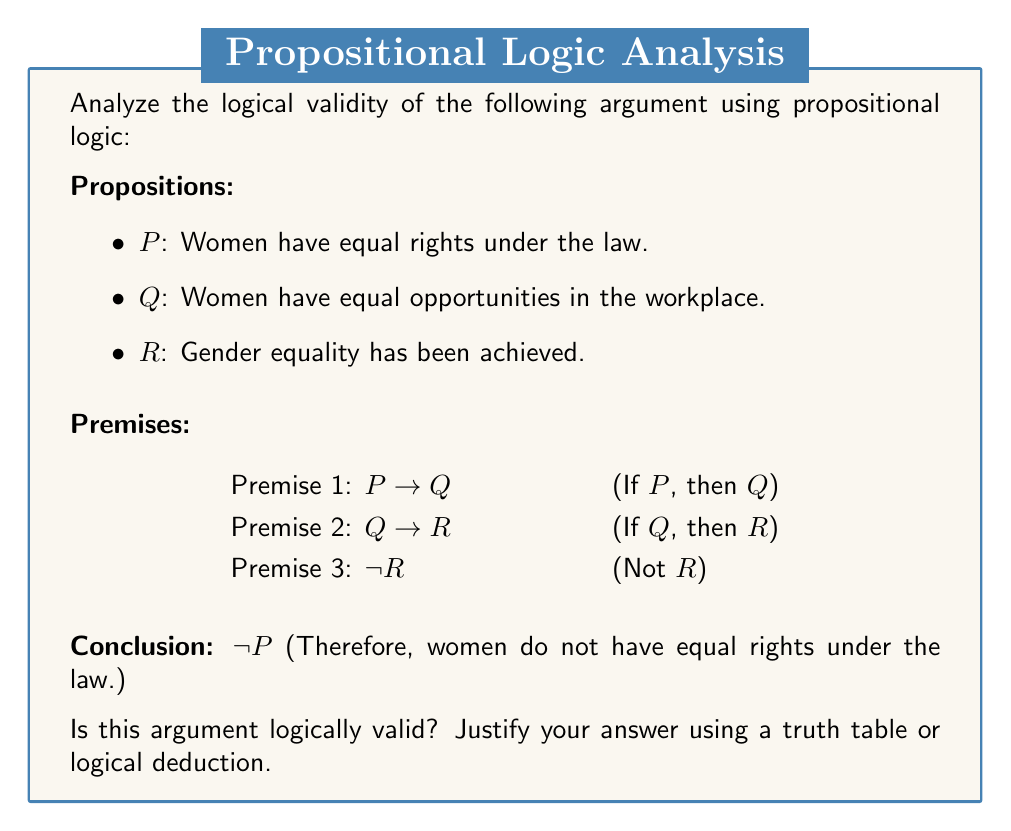Could you help me with this problem? To determine the logical validity of this argument, we need to examine if the conclusion necessarily follows from the premises. Let's approach this step-by-step using propositional logic:

1. First, let's write out the logical structure of the argument:
   $$(P \rightarrow Q) \land (Q \rightarrow R) \land \neg R \therefore \neg P$$

2. We can use the method of contradiction to prove validity. Let's assume the premises are true but the conclusion is false:
   $$(P \rightarrow Q) \land (Q \rightarrow R) \land \neg R \land P$$

3. From the premises $P \rightarrow Q$ and $P$, we can deduce $Q$ using Modus Ponens:
   $$P \rightarrow Q, P \therefore Q$$

4. From $Q \rightarrow R$ and $Q$, we can deduce $R$:
   $$Q \rightarrow R, Q \therefore R$$

5. However, we also have $\neg R$ as a premise, which contradicts $R$.

6. This contradiction shows that our assumption (premises true, conclusion false) is impossible.

7. Therefore, if all premises are true, the conclusion must also be true, which means the argument is logically valid.

Note: This doesn't mean the argument is sound (i.e., that the premises are actually true in reality). It only means that IF the premises are true, then the conclusion MUST be true.
Answer: The argument is logically valid. 